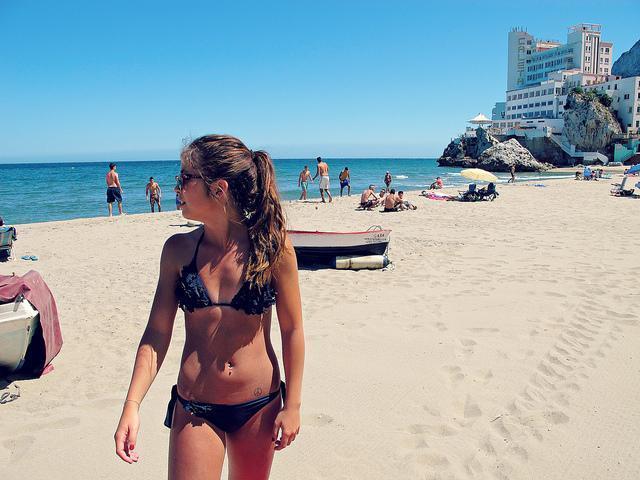How many boats can be seen?
Give a very brief answer. 2. 